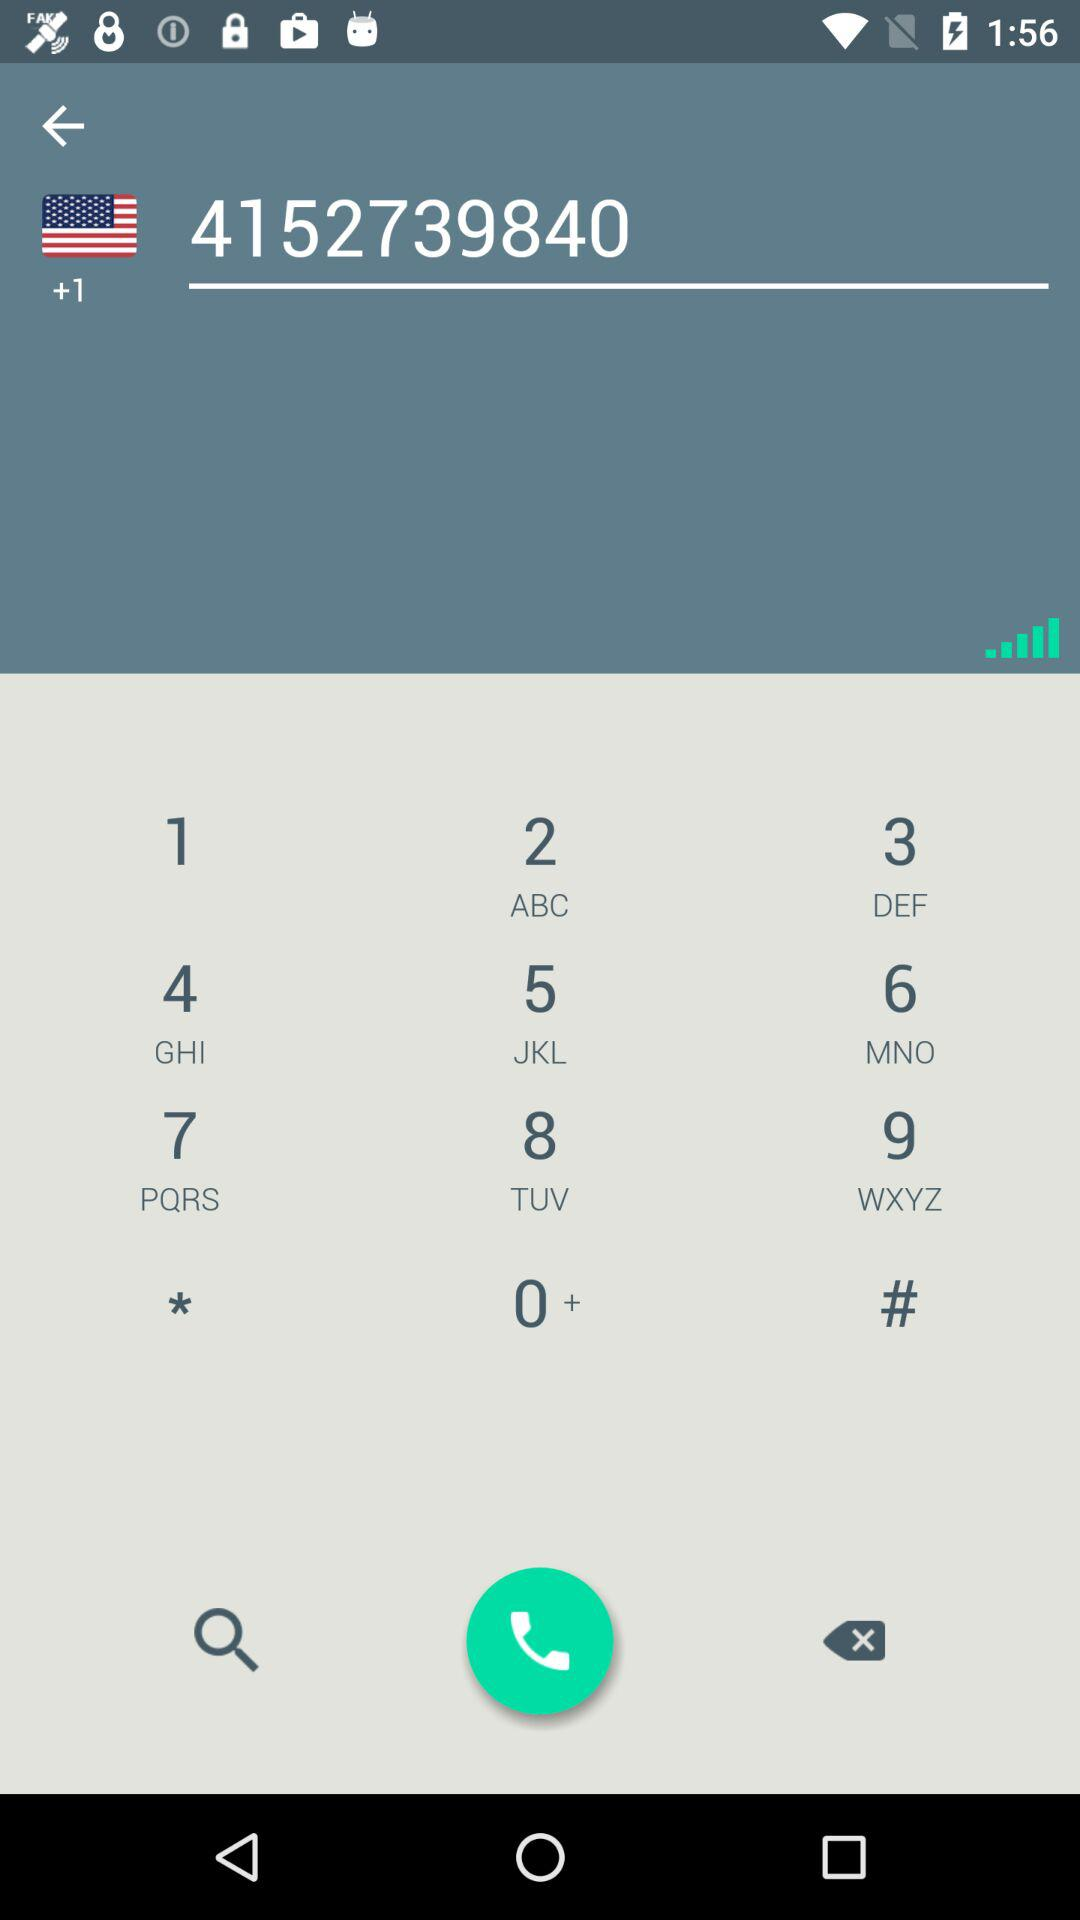Who are the people in the user's contacts?
When the provided information is insufficient, respond with <no answer>. <no answer> 